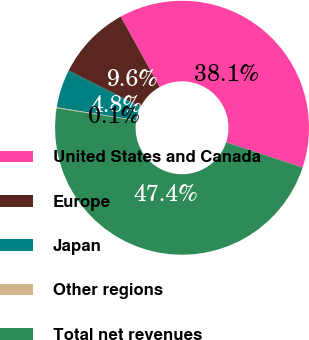Convert chart to OTSL. <chart><loc_0><loc_0><loc_500><loc_500><pie_chart><fcel>United States and Canada<fcel>Europe<fcel>Japan<fcel>Other regions<fcel>Total net revenues<nl><fcel>38.08%<fcel>9.57%<fcel>4.84%<fcel>0.12%<fcel>47.38%<nl></chart> 